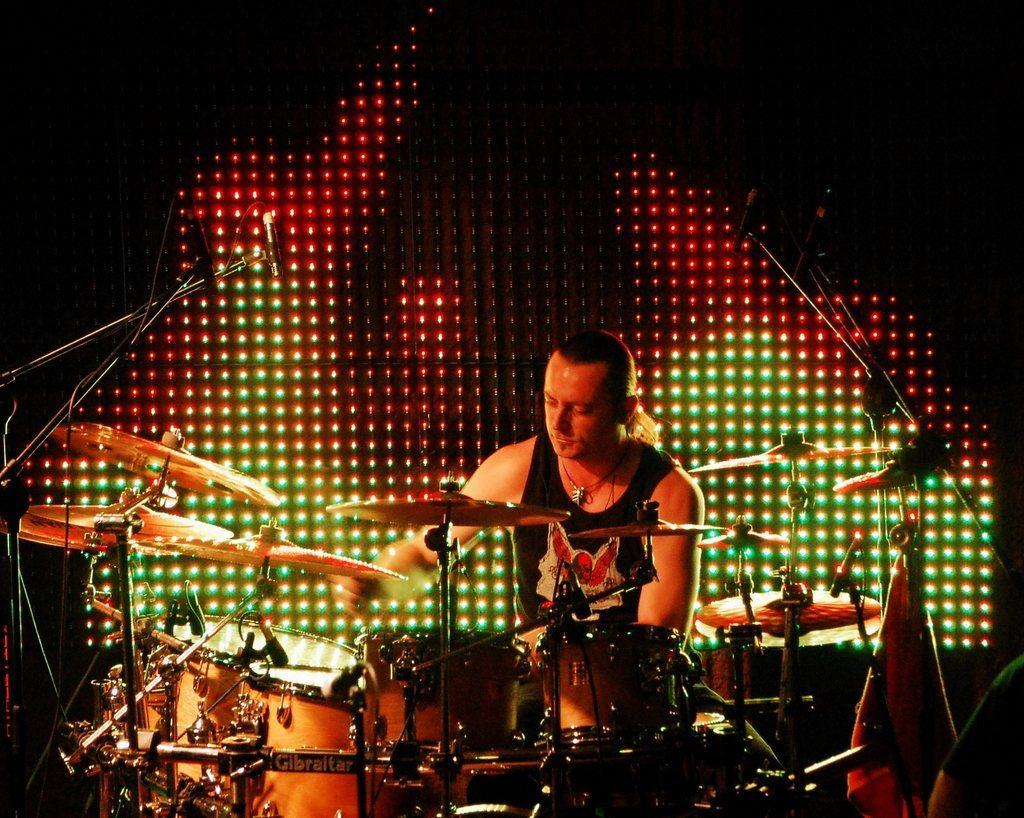How would you summarize this image in a sentence or two? This image consists of a man wearing black sleeveless. He is playing drums, in the front there is a drum set along with mics. In the background, there is a screen to which there are lights. 